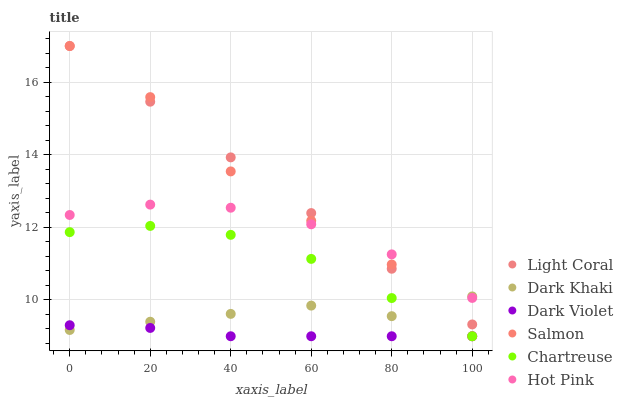Does Dark Violet have the minimum area under the curve?
Answer yes or no. Yes. Does Light Coral have the maximum area under the curve?
Answer yes or no. Yes. Does Hot Pink have the minimum area under the curve?
Answer yes or no. No. Does Hot Pink have the maximum area under the curve?
Answer yes or no. No. Is Light Coral the smoothest?
Answer yes or no. Yes. Is Salmon the roughest?
Answer yes or no. Yes. Is Hot Pink the smoothest?
Answer yes or no. No. Is Hot Pink the roughest?
Answer yes or no. No. Does Salmon have the lowest value?
Answer yes or no. Yes. Does Hot Pink have the lowest value?
Answer yes or no. No. Does Light Coral have the highest value?
Answer yes or no. Yes. Does Hot Pink have the highest value?
Answer yes or no. No. Is Dark Violet less than Light Coral?
Answer yes or no. Yes. Is Hot Pink greater than Dark Violet?
Answer yes or no. Yes. Does Chartreuse intersect Dark Violet?
Answer yes or no. Yes. Is Chartreuse less than Dark Violet?
Answer yes or no. No. Is Chartreuse greater than Dark Violet?
Answer yes or no. No. Does Dark Violet intersect Light Coral?
Answer yes or no. No. 